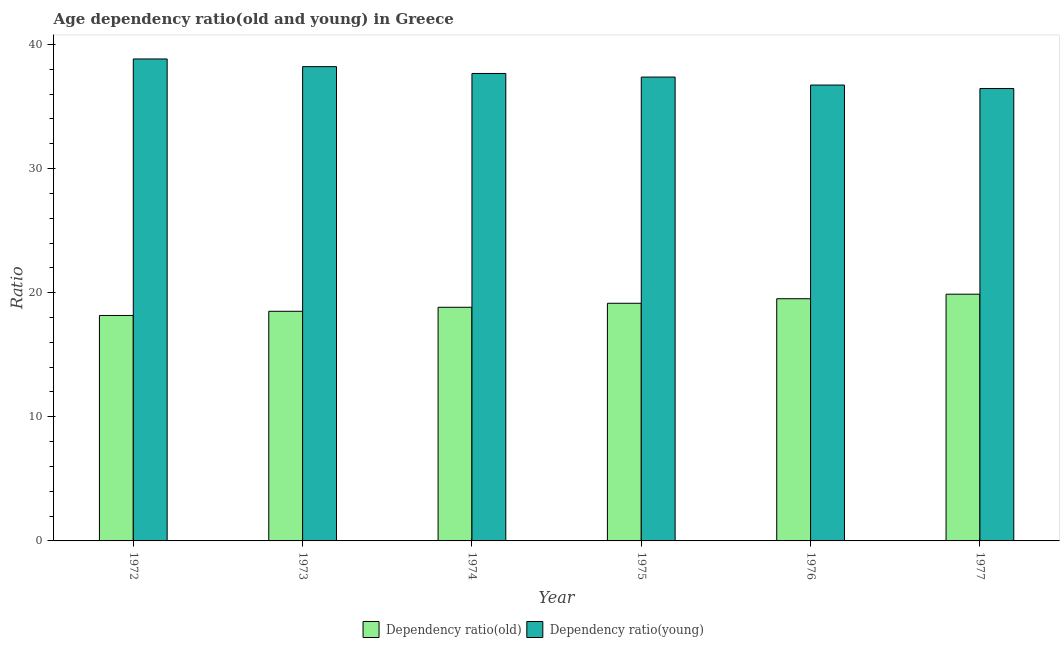Are the number of bars per tick equal to the number of legend labels?
Provide a short and direct response. Yes. Are the number of bars on each tick of the X-axis equal?
Your response must be concise. Yes. How many bars are there on the 4th tick from the left?
Offer a very short reply. 2. In how many cases, is the number of bars for a given year not equal to the number of legend labels?
Give a very brief answer. 0. What is the age dependency ratio(young) in 1972?
Keep it short and to the point. 38.83. Across all years, what is the maximum age dependency ratio(young)?
Keep it short and to the point. 38.83. Across all years, what is the minimum age dependency ratio(young)?
Provide a short and direct response. 36.45. In which year was the age dependency ratio(old) maximum?
Provide a succinct answer. 1977. What is the total age dependency ratio(old) in the graph?
Provide a succinct answer. 114.03. What is the difference between the age dependency ratio(young) in 1973 and that in 1975?
Your answer should be compact. 0.84. What is the difference between the age dependency ratio(young) in 1977 and the age dependency ratio(old) in 1974?
Offer a very short reply. -1.22. What is the average age dependency ratio(young) per year?
Offer a very short reply. 37.54. In how many years, is the age dependency ratio(old) greater than 2?
Your response must be concise. 6. What is the ratio of the age dependency ratio(old) in 1973 to that in 1974?
Your response must be concise. 0.98. What is the difference between the highest and the second highest age dependency ratio(young)?
Provide a succinct answer. 0.62. What is the difference between the highest and the lowest age dependency ratio(young)?
Provide a succinct answer. 2.38. In how many years, is the age dependency ratio(old) greater than the average age dependency ratio(old) taken over all years?
Your response must be concise. 3. What does the 1st bar from the left in 1972 represents?
Ensure brevity in your answer.  Dependency ratio(old). What does the 1st bar from the right in 1972 represents?
Your response must be concise. Dependency ratio(young). How many years are there in the graph?
Your answer should be compact. 6. What is the difference between two consecutive major ticks on the Y-axis?
Your answer should be compact. 10. What is the title of the graph?
Your response must be concise. Age dependency ratio(old and young) in Greece. What is the label or title of the Y-axis?
Offer a terse response. Ratio. What is the Ratio of Dependency ratio(old) in 1972?
Your answer should be compact. 18.16. What is the Ratio of Dependency ratio(young) in 1972?
Give a very brief answer. 38.83. What is the Ratio of Dependency ratio(old) in 1973?
Provide a short and direct response. 18.5. What is the Ratio in Dependency ratio(young) in 1973?
Offer a terse response. 38.21. What is the Ratio in Dependency ratio(old) in 1974?
Your answer should be very brief. 18.83. What is the Ratio of Dependency ratio(young) in 1974?
Provide a succinct answer. 37.66. What is the Ratio of Dependency ratio(old) in 1975?
Your answer should be compact. 19.15. What is the Ratio of Dependency ratio(young) in 1975?
Keep it short and to the point. 37.37. What is the Ratio of Dependency ratio(old) in 1976?
Your response must be concise. 19.51. What is the Ratio of Dependency ratio(young) in 1976?
Your answer should be compact. 36.73. What is the Ratio of Dependency ratio(old) in 1977?
Your answer should be very brief. 19.88. What is the Ratio in Dependency ratio(young) in 1977?
Your answer should be very brief. 36.45. Across all years, what is the maximum Ratio in Dependency ratio(old)?
Offer a very short reply. 19.88. Across all years, what is the maximum Ratio of Dependency ratio(young)?
Ensure brevity in your answer.  38.83. Across all years, what is the minimum Ratio in Dependency ratio(old)?
Offer a terse response. 18.16. Across all years, what is the minimum Ratio in Dependency ratio(young)?
Offer a terse response. 36.45. What is the total Ratio of Dependency ratio(old) in the graph?
Your response must be concise. 114.03. What is the total Ratio of Dependency ratio(young) in the graph?
Provide a short and direct response. 225.26. What is the difference between the Ratio of Dependency ratio(old) in 1972 and that in 1973?
Make the answer very short. -0.34. What is the difference between the Ratio in Dependency ratio(young) in 1972 and that in 1973?
Your response must be concise. 0.62. What is the difference between the Ratio of Dependency ratio(old) in 1972 and that in 1974?
Your answer should be very brief. -0.66. What is the difference between the Ratio of Dependency ratio(young) in 1972 and that in 1974?
Your response must be concise. 1.17. What is the difference between the Ratio in Dependency ratio(old) in 1972 and that in 1975?
Make the answer very short. -0.98. What is the difference between the Ratio in Dependency ratio(young) in 1972 and that in 1975?
Your response must be concise. 1.46. What is the difference between the Ratio in Dependency ratio(old) in 1972 and that in 1976?
Provide a short and direct response. -1.35. What is the difference between the Ratio of Dependency ratio(young) in 1972 and that in 1976?
Your answer should be very brief. 2.1. What is the difference between the Ratio of Dependency ratio(old) in 1972 and that in 1977?
Your answer should be compact. -1.71. What is the difference between the Ratio in Dependency ratio(young) in 1972 and that in 1977?
Offer a very short reply. 2.38. What is the difference between the Ratio in Dependency ratio(old) in 1973 and that in 1974?
Keep it short and to the point. -0.32. What is the difference between the Ratio of Dependency ratio(young) in 1973 and that in 1974?
Offer a very short reply. 0.55. What is the difference between the Ratio in Dependency ratio(old) in 1973 and that in 1975?
Give a very brief answer. -0.64. What is the difference between the Ratio in Dependency ratio(young) in 1973 and that in 1975?
Your answer should be very brief. 0.84. What is the difference between the Ratio of Dependency ratio(old) in 1973 and that in 1976?
Provide a succinct answer. -1.01. What is the difference between the Ratio of Dependency ratio(young) in 1973 and that in 1976?
Ensure brevity in your answer.  1.48. What is the difference between the Ratio of Dependency ratio(old) in 1973 and that in 1977?
Your answer should be very brief. -1.38. What is the difference between the Ratio of Dependency ratio(young) in 1973 and that in 1977?
Offer a very short reply. 1.76. What is the difference between the Ratio in Dependency ratio(old) in 1974 and that in 1975?
Ensure brevity in your answer.  -0.32. What is the difference between the Ratio of Dependency ratio(young) in 1974 and that in 1975?
Keep it short and to the point. 0.29. What is the difference between the Ratio of Dependency ratio(old) in 1974 and that in 1976?
Your response must be concise. -0.69. What is the difference between the Ratio of Dependency ratio(young) in 1974 and that in 1976?
Provide a short and direct response. 0.93. What is the difference between the Ratio in Dependency ratio(old) in 1974 and that in 1977?
Your answer should be compact. -1.05. What is the difference between the Ratio of Dependency ratio(young) in 1974 and that in 1977?
Your response must be concise. 1.22. What is the difference between the Ratio in Dependency ratio(old) in 1975 and that in 1976?
Your answer should be compact. -0.37. What is the difference between the Ratio in Dependency ratio(young) in 1975 and that in 1976?
Offer a very short reply. 0.64. What is the difference between the Ratio in Dependency ratio(old) in 1975 and that in 1977?
Your answer should be compact. -0.73. What is the difference between the Ratio of Dependency ratio(young) in 1975 and that in 1977?
Offer a very short reply. 0.92. What is the difference between the Ratio of Dependency ratio(old) in 1976 and that in 1977?
Ensure brevity in your answer.  -0.36. What is the difference between the Ratio of Dependency ratio(young) in 1976 and that in 1977?
Offer a terse response. 0.28. What is the difference between the Ratio in Dependency ratio(old) in 1972 and the Ratio in Dependency ratio(young) in 1973?
Ensure brevity in your answer.  -20.05. What is the difference between the Ratio in Dependency ratio(old) in 1972 and the Ratio in Dependency ratio(young) in 1974?
Your response must be concise. -19.5. What is the difference between the Ratio of Dependency ratio(old) in 1972 and the Ratio of Dependency ratio(young) in 1975?
Offer a terse response. -19.21. What is the difference between the Ratio of Dependency ratio(old) in 1972 and the Ratio of Dependency ratio(young) in 1976?
Ensure brevity in your answer.  -18.57. What is the difference between the Ratio in Dependency ratio(old) in 1972 and the Ratio in Dependency ratio(young) in 1977?
Your answer should be compact. -18.29. What is the difference between the Ratio in Dependency ratio(old) in 1973 and the Ratio in Dependency ratio(young) in 1974?
Offer a terse response. -19.16. What is the difference between the Ratio in Dependency ratio(old) in 1973 and the Ratio in Dependency ratio(young) in 1975?
Offer a terse response. -18.87. What is the difference between the Ratio of Dependency ratio(old) in 1973 and the Ratio of Dependency ratio(young) in 1976?
Offer a terse response. -18.23. What is the difference between the Ratio in Dependency ratio(old) in 1973 and the Ratio in Dependency ratio(young) in 1977?
Offer a terse response. -17.95. What is the difference between the Ratio of Dependency ratio(old) in 1974 and the Ratio of Dependency ratio(young) in 1975?
Offer a very short reply. -18.55. What is the difference between the Ratio of Dependency ratio(old) in 1974 and the Ratio of Dependency ratio(young) in 1976?
Give a very brief answer. -17.9. What is the difference between the Ratio in Dependency ratio(old) in 1974 and the Ratio in Dependency ratio(young) in 1977?
Provide a succinct answer. -17.62. What is the difference between the Ratio of Dependency ratio(old) in 1975 and the Ratio of Dependency ratio(young) in 1976?
Ensure brevity in your answer.  -17.58. What is the difference between the Ratio in Dependency ratio(old) in 1975 and the Ratio in Dependency ratio(young) in 1977?
Provide a succinct answer. -17.3. What is the difference between the Ratio of Dependency ratio(old) in 1976 and the Ratio of Dependency ratio(young) in 1977?
Give a very brief answer. -16.94. What is the average Ratio in Dependency ratio(old) per year?
Provide a succinct answer. 19.01. What is the average Ratio of Dependency ratio(young) per year?
Give a very brief answer. 37.54. In the year 1972, what is the difference between the Ratio of Dependency ratio(old) and Ratio of Dependency ratio(young)?
Provide a short and direct response. -20.67. In the year 1973, what is the difference between the Ratio of Dependency ratio(old) and Ratio of Dependency ratio(young)?
Keep it short and to the point. -19.71. In the year 1974, what is the difference between the Ratio in Dependency ratio(old) and Ratio in Dependency ratio(young)?
Provide a short and direct response. -18.84. In the year 1975, what is the difference between the Ratio of Dependency ratio(old) and Ratio of Dependency ratio(young)?
Provide a succinct answer. -18.23. In the year 1976, what is the difference between the Ratio of Dependency ratio(old) and Ratio of Dependency ratio(young)?
Keep it short and to the point. -17.22. In the year 1977, what is the difference between the Ratio in Dependency ratio(old) and Ratio in Dependency ratio(young)?
Offer a terse response. -16.57. What is the ratio of the Ratio of Dependency ratio(old) in 1972 to that in 1973?
Make the answer very short. 0.98. What is the ratio of the Ratio of Dependency ratio(young) in 1972 to that in 1973?
Give a very brief answer. 1.02. What is the ratio of the Ratio of Dependency ratio(old) in 1972 to that in 1974?
Keep it short and to the point. 0.96. What is the ratio of the Ratio in Dependency ratio(young) in 1972 to that in 1974?
Keep it short and to the point. 1.03. What is the ratio of the Ratio in Dependency ratio(old) in 1972 to that in 1975?
Keep it short and to the point. 0.95. What is the ratio of the Ratio of Dependency ratio(young) in 1972 to that in 1975?
Keep it short and to the point. 1.04. What is the ratio of the Ratio in Dependency ratio(old) in 1972 to that in 1976?
Keep it short and to the point. 0.93. What is the ratio of the Ratio in Dependency ratio(young) in 1972 to that in 1976?
Provide a succinct answer. 1.06. What is the ratio of the Ratio in Dependency ratio(old) in 1972 to that in 1977?
Make the answer very short. 0.91. What is the ratio of the Ratio in Dependency ratio(young) in 1972 to that in 1977?
Keep it short and to the point. 1.07. What is the ratio of the Ratio in Dependency ratio(old) in 1973 to that in 1974?
Your response must be concise. 0.98. What is the ratio of the Ratio of Dependency ratio(young) in 1973 to that in 1974?
Offer a terse response. 1.01. What is the ratio of the Ratio of Dependency ratio(old) in 1973 to that in 1975?
Make the answer very short. 0.97. What is the ratio of the Ratio of Dependency ratio(young) in 1973 to that in 1975?
Your answer should be compact. 1.02. What is the ratio of the Ratio of Dependency ratio(old) in 1973 to that in 1976?
Keep it short and to the point. 0.95. What is the ratio of the Ratio of Dependency ratio(young) in 1973 to that in 1976?
Make the answer very short. 1.04. What is the ratio of the Ratio of Dependency ratio(old) in 1973 to that in 1977?
Ensure brevity in your answer.  0.93. What is the ratio of the Ratio in Dependency ratio(young) in 1973 to that in 1977?
Provide a short and direct response. 1.05. What is the ratio of the Ratio in Dependency ratio(old) in 1974 to that in 1975?
Make the answer very short. 0.98. What is the ratio of the Ratio of Dependency ratio(old) in 1974 to that in 1976?
Keep it short and to the point. 0.96. What is the ratio of the Ratio in Dependency ratio(young) in 1974 to that in 1976?
Your answer should be very brief. 1.03. What is the ratio of the Ratio in Dependency ratio(old) in 1974 to that in 1977?
Your answer should be compact. 0.95. What is the ratio of the Ratio in Dependency ratio(old) in 1975 to that in 1976?
Provide a succinct answer. 0.98. What is the ratio of the Ratio in Dependency ratio(young) in 1975 to that in 1976?
Give a very brief answer. 1.02. What is the ratio of the Ratio of Dependency ratio(old) in 1975 to that in 1977?
Make the answer very short. 0.96. What is the ratio of the Ratio of Dependency ratio(young) in 1975 to that in 1977?
Your answer should be very brief. 1.03. What is the ratio of the Ratio of Dependency ratio(old) in 1976 to that in 1977?
Offer a very short reply. 0.98. What is the ratio of the Ratio in Dependency ratio(young) in 1976 to that in 1977?
Give a very brief answer. 1.01. What is the difference between the highest and the second highest Ratio of Dependency ratio(old)?
Keep it short and to the point. 0.36. What is the difference between the highest and the second highest Ratio of Dependency ratio(young)?
Keep it short and to the point. 0.62. What is the difference between the highest and the lowest Ratio of Dependency ratio(old)?
Your answer should be very brief. 1.71. What is the difference between the highest and the lowest Ratio in Dependency ratio(young)?
Your answer should be very brief. 2.38. 